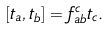Convert formula to latex. <formula><loc_0><loc_0><loc_500><loc_500>[ t _ { a } , t _ { b } ] = f _ { a b } ^ { c } t _ { c } .</formula> 